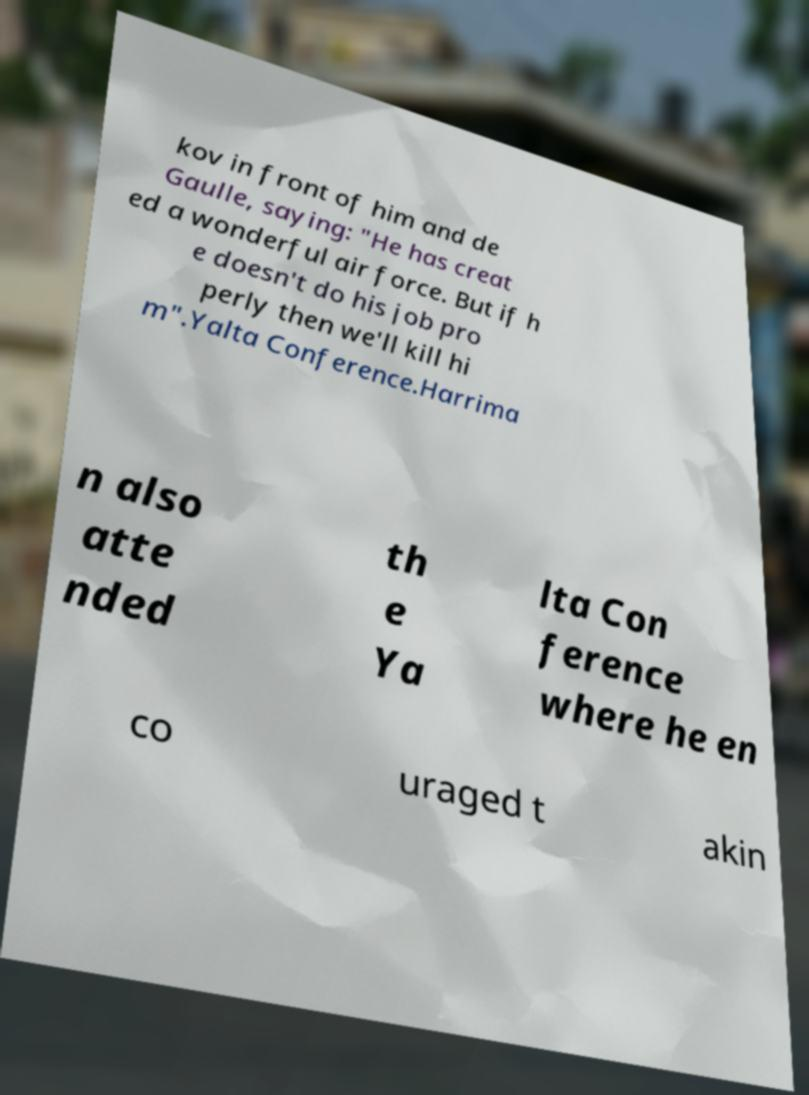I need the written content from this picture converted into text. Can you do that? kov in front of him and de Gaulle, saying: "He has creat ed a wonderful air force. But if h e doesn't do his job pro perly then we'll kill hi m".Yalta Conference.Harrima n also atte nded th e Ya lta Con ference where he en co uraged t akin 